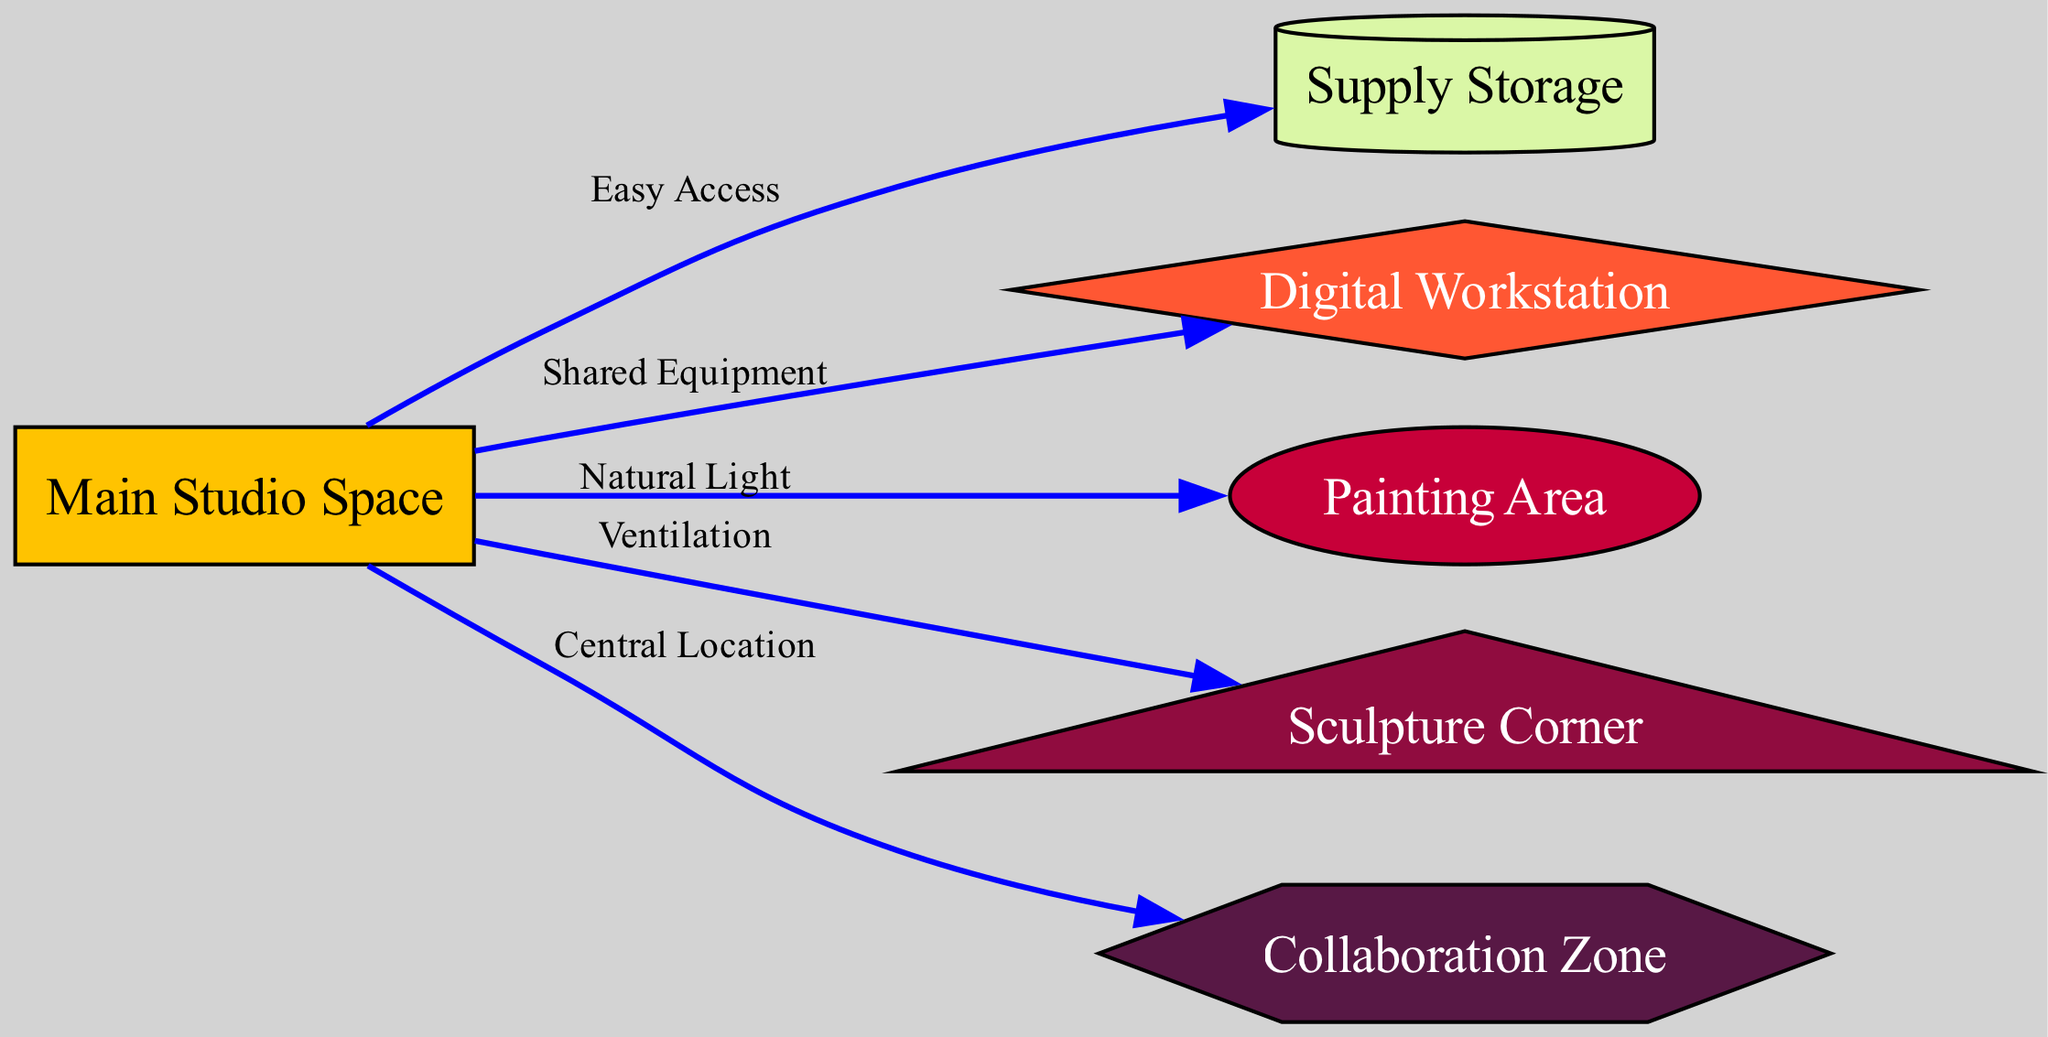What is the total number of nodes in the diagram? By counting the individual elements in the "nodes" section of the provided data, we can see there are six nodes labeled as Main Studio Space, Supply Storage, Digital Workstation, Painting Area, Sculpture Corner, and Collaboration Zone.
Answer: 6 What is the relationship between the studio and the storage? The diagram indicates an edge from "studio" to "storage" labeled as "Easy Access," which signifies a direct connection denoting ease of retrieving supplies from storage.
Answer: Easy Access Which area has natural light according to the diagram? The edge from "studio" to "painting" is labeled "Natural Light," indicating that the painting area benefits from natural lighting sourced from the main studio.
Answer: Painting Area What shape represents the Digital Workstation? In the diagram's node definitions, the Digital Workstation is characterized by a "diamond" shape, which helps visually distinguish it from other areas in the studio layout.
Answer: Diamond What is the central location in the studio layout? The edge from "studio" to "collab" is labeled "Central Location," indicating that the Collaboration Zone serves as a pivotal area for collective activities within the studio.
Answer: Central Location How does the diagram ensure ventilation for artistic tasks? The diagram illustrates an edge from "studio" to "sculpture" labeled "Ventilation," ensuring that the sculpture area has the necessary airflow for safety and comfort during sculpting activities.
Answer: Ventilation What common feature connects the main studio to the different areas? All edges connect the main studio to various areas (storage, digital, painting, sculpture, and collaboration), indicating that the central studio acts as the hub or common feature facilitating various artistic tasks.
Answer: Common Feature How many edges indicate direct access from the studio? There are five edges originating from the "studio," connecting it to the storage, digital workstation, painting area, sculpture corner, and collaboration zone.
Answer: 5 Which area is specifically designated for collaboration? The node labeled "Collaboration Zone" distinctly identifies the space meant specifically for collaborative art projects within the studio layout.
Answer: Collaboration Zone 